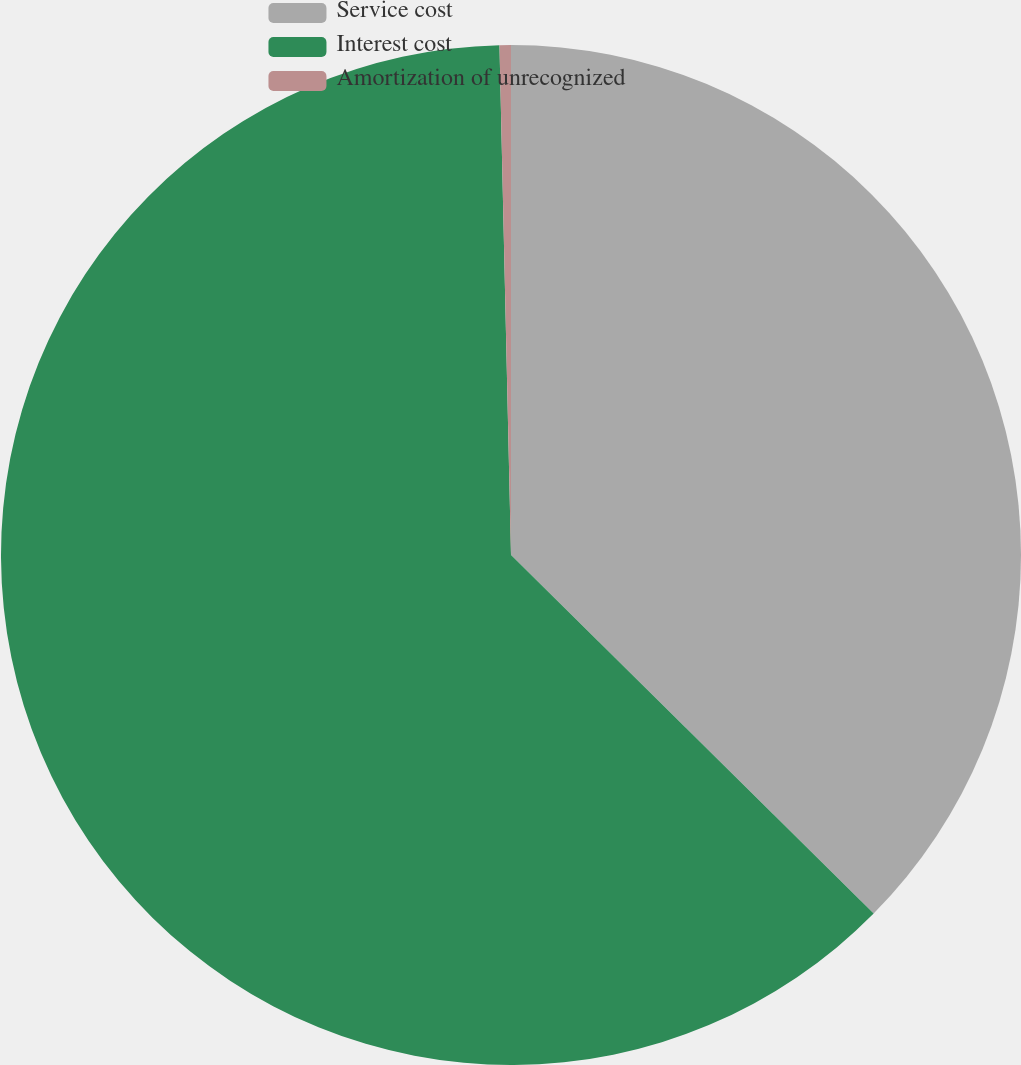<chart> <loc_0><loc_0><loc_500><loc_500><pie_chart><fcel>Service cost<fcel>Interest cost<fcel>Amortization of unrecognized<nl><fcel>37.41%<fcel>62.23%<fcel>0.36%<nl></chart> 